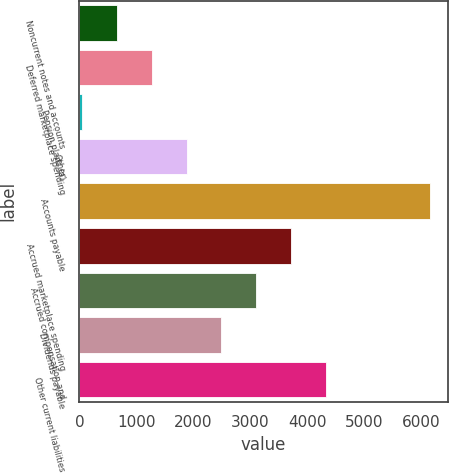Convert chart to OTSL. <chart><loc_0><loc_0><loc_500><loc_500><bar_chart><fcel>Noncurrent notes and accounts<fcel>Deferred marketplace spending<fcel>Pension plans (a)<fcel>Other<fcel>Accounts payable<fcel>Accrued marketplace spending<fcel>Accrued compensation and<fcel>Dividends payable<fcel>Other current liabilities<nl><fcel>663.5<fcel>1274<fcel>53<fcel>1884.5<fcel>6158<fcel>3716<fcel>3105.5<fcel>2495<fcel>4326.5<nl></chart> 